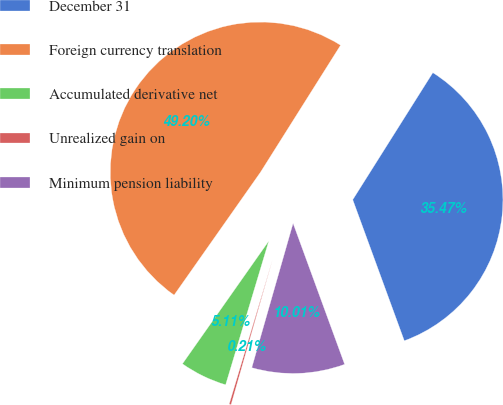Convert chart. <chart><loc_0><loc_0><loc_500><loc_500><pie_chart><fcel>December 31<fcel>Foreign currency translation<fcel>Accumulated derivative net<fcel>Unrealized gain on<fcel>Minimum pension liability<nl><fcel>35.47%<fcel>49.2%<fcel>5.11%<fcel>0.21%<fcel>10.01%<nl></chart> 